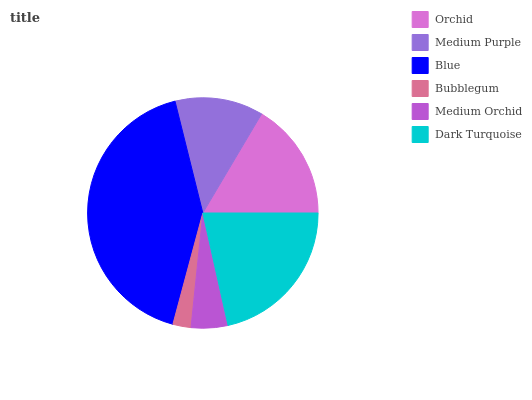Is Bubblegum the minimum?
Answer yes or no. Yes. Is Blue the maximum?
Answer yes or no. Yes. Is Medium Purple the minimum?
Answer yes or no. No. Is Medium Purple the maximum?
Answer yes or no. No. Is Orchid greater than Medium Purple?
Answer yes or no. Yes. Is Medium Purple less than Orchid?
Answer yes or no. Yes. Is Medium Purple greater than Orchid?
Answer yes or no. No. Is Orchid less than Medium Purple?
Answer yes or no. No. Is Orchid the high median?
Answer yes or no. Yes. Is Medium Purple the low median?
Answer yes or no. Yes. Is Dark Turquoise the high median?
Answer yes or no. No. Is Blue the low median?
Answer yes or no. No. 